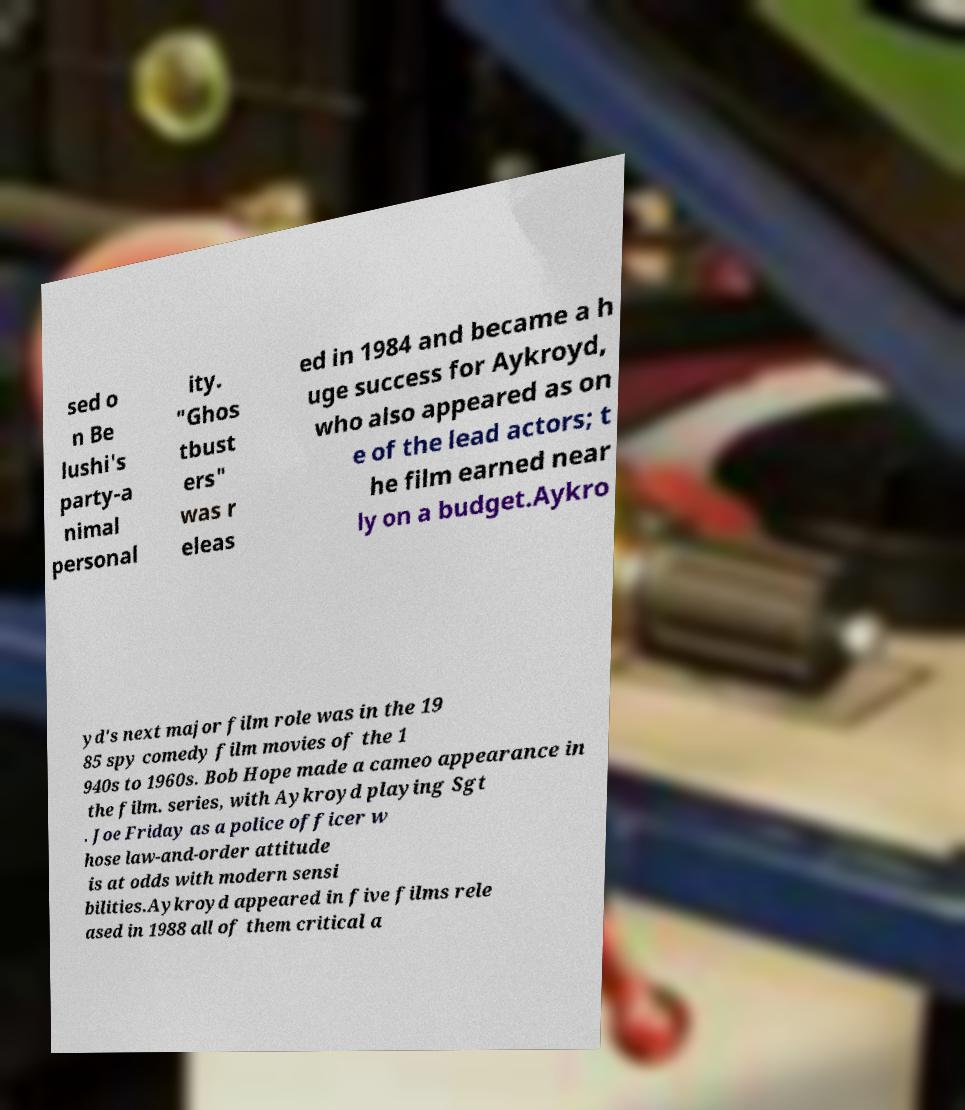Can you accurately transcribe the text from the provided image for me? sed o n Be lushi's party-a nimal personal ity. "Ghos tbust ers" was r eleas ed in 1984 and became a h uge success for Aykroyd, who also appeared as on e of the lead actors; t he film earned near ly on a budget.Aykro yd's next major film role was in the 19 85 spy comedy film movies of the 1 940s to 1960s. Bob Hope made a cameo appearance in the film. series, with Aykroyd playing Sgt . Joe Friday as a police officer w hose law-and-order attitude is at odds with modern sensi bilities.Aykroyd appeared in five films rele ased in 1988 all of them critical a 